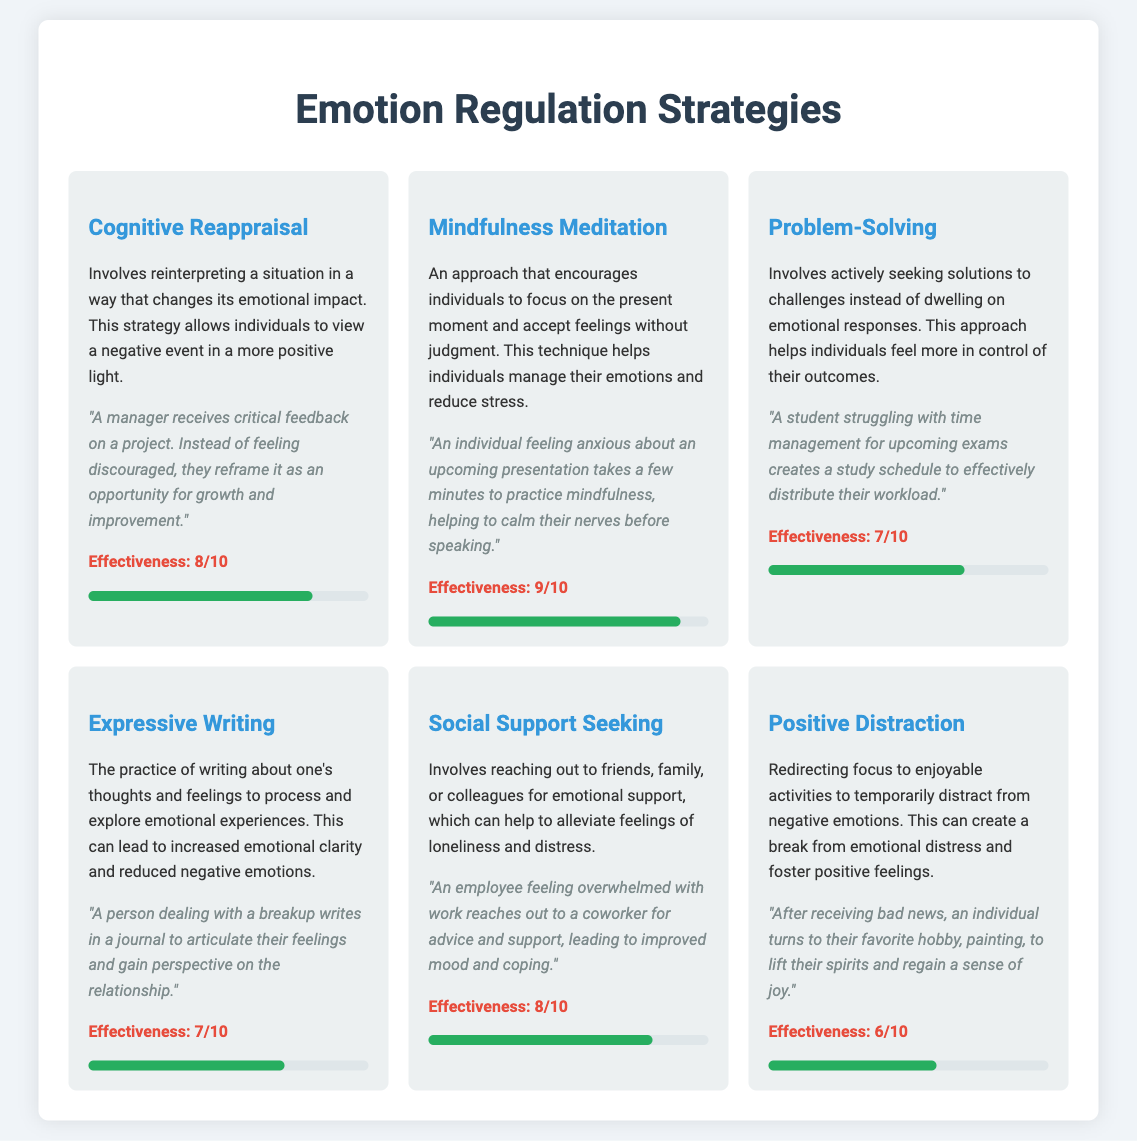what is the title of the document? The title of the document is indicated at the top of the page.
Answer: Emotion Regulation Strategies how many emotion regulation strategies are listed? Each strategy is contained within its own card, and there are six strategies presented in the document.
Answer: 6 what is the effectiveness rating of Cognitive Reappraisal? Each strategy includes a rating that indicates its effectiveness, which is provided as a number.
Answer: 8/10 what scenario is provided for Mindfulness Meditation? The scenario adjacent to a strategy describes a specific context in which the strategy is applicable.
Answer: "An individual feeling anxious about an upcoming presentation takes a few minutes to practice mindfulness..." name one emotion regulation strategy with a rating of 7/10. The document contains strategies with various ratings, and there are strategies rated 7/10 mentioned.
Answer: Problem-Solving which strategy has the highest effectiveness rating? The highest rating is noted in the effectiveness section of each strategy card.
Answer: Mindfulness Meditation what is the purpose of Expressive Writing? The description of the strategy outlines its intended function and benefits.
Answer: To process and explore emotional experiences how does Social Support Seeking affect feelings? Each strategy discusses its impact on emotional states, particularly how it helps alleviate specific emotions.
Answer: Alleviate feelings of loneliness and distress what background color is used for the webpage? The background color is set in the CSS and affects the entire document area.
Answer: #f0f4f8 